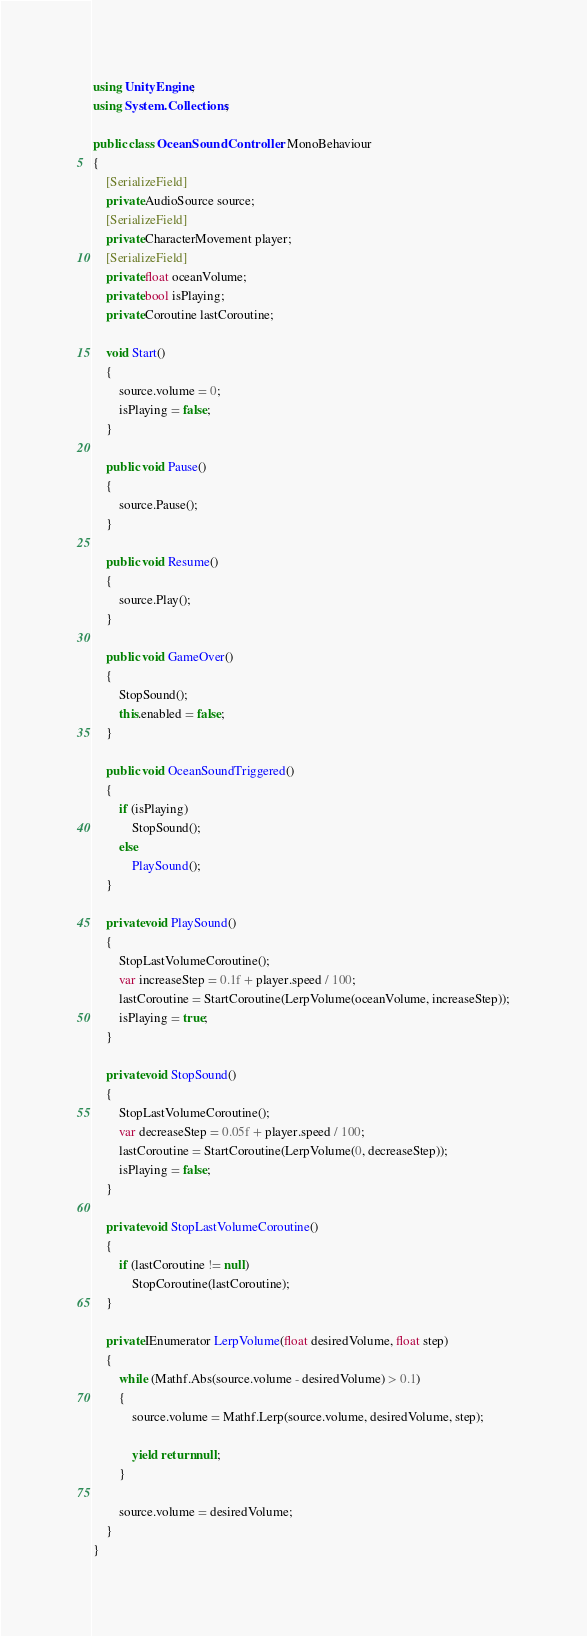<code> <loc_0><loc_0><loc_500><loc_500><_C#_>using UnityEngine;
using System.Collections;

public class OceanSoundController : MonoBehaviour
{
    [SerializeField]
    private AudioSource source;
    [SerializeField]
    private CharacterMovement player;
    [SerializeField]
    private float oceanVolume;
    private bool isPlaying;
    private Coroutine lastCoroutine;

    void Start()
    {
        source.volume = 0;
        isPlaying = false;
    }

    public void Pause()
    {
        source.Pause();
    }

    public void Resume()
    {
        source.Play();
    }

    public void GameOver()
    {
        StopSound();
        this.enabled = false;
    }

    public void OceanSoundTriggered()
    {
        if (isPlaying)
            StopSound();
        else
            PlaySound();
    }

    private void PlaySound()
    {
        StopLastVolumeCoroutine();
        var increaseStep = 0.1f + player.speed / 100;
        lastCoroutine = StartCoroutine(LerpVolume(oceanVolume, increaseStep));
        isPlaying = true;
    }

    private void StopSound()
    {
        StopLastVolumeCoroutine();
        var decreaseStep = 0.05f + player.speed / 100;
        lastCoroutine = StartCoroutine(LerpVolume(0, decreaseStep));
        isPlaying = false;
    }

    private void StopLastVolumeCoroutine()
    {
        if (lastCoroutine != null)
            StopCoroutine(lastCoroutine);
    }

    private IEnumerator LerpVolume(float desiredVolume, float step)
    {
        while (Mathf.Abs(source.volume - desiredVolume) > 0.1)
        {
            source.volume = Mathf.Lerp(source.volume, desiredVolume, step);

            yield return null;
        }

        source.volume = desiredVolume;
    }
}
</code> 